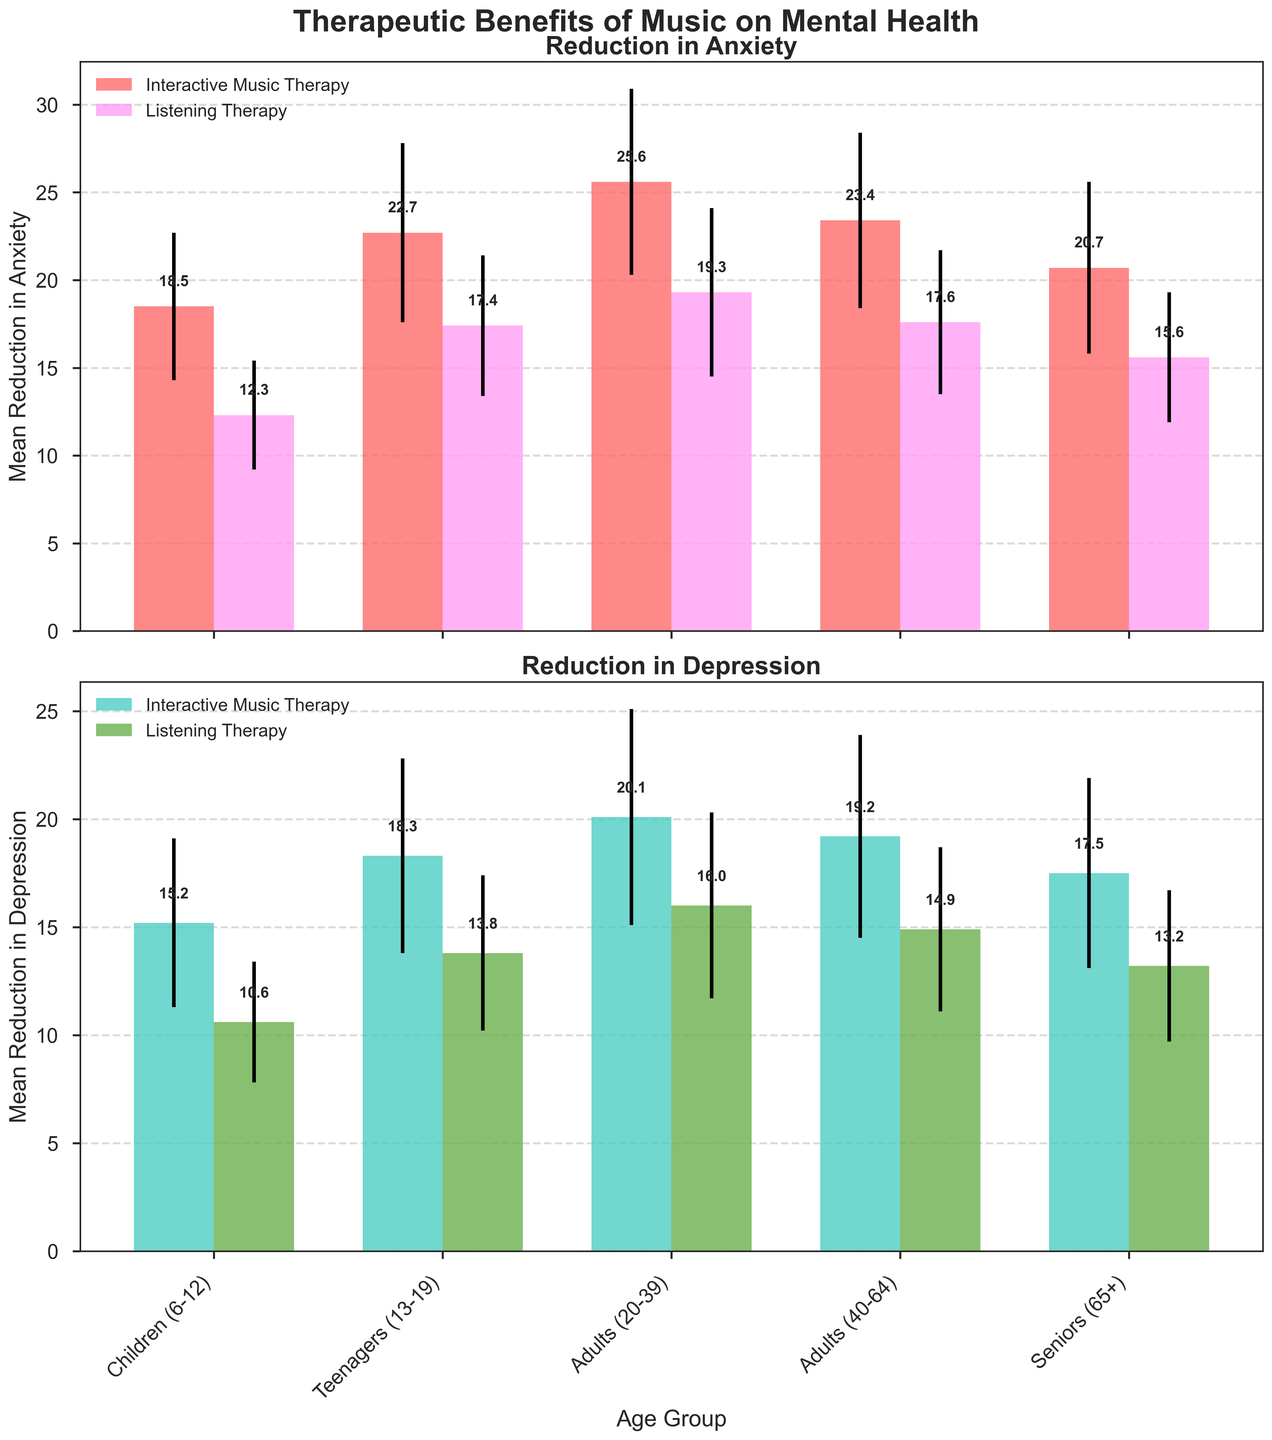Which age group has the highest mean reduction in anxiety with Interactive Music Therapy? To find this, look at the top subplot "Reduction in Anxiety" and compare the heights of the red bars for all age groups. The highest red bar corresponds to Adults (20-39) with a mean reduction of 25.6.
Answer: Adults (20-39) What is the average mean reduction in depression for Listening Therapy across all age groups? Calculate the average by summing the mean reductions in depression for Listening Therapy for all age groups and dividing by the number of age groups. (15.2 + 10.6 + 18.3 + 13.8 + 20.1 + 16.0 + 19.2 + 14.9 + 17.5 + 13.2) / 10 = 14.76
Answer: 14.76 Which type of music therapy shows a higher mean reduction in anxiety for Seniors (65+)? Compare the heights of the two bars for Seniors (65+) in the top subplot "Reduction in Anxiety." The red bar (Interactive Music Therapy) is higher than the green bar (Listening Therapy), indicating a higher mean reduction.
Answer: Interactive Music Therapy What is the difference in mean reduction in depression between Interactive and Listening Therapy for Teenagers (13-19)? Find the mean reduction values for both therapies for Teenagers (13-19) in the bottom subplot "Reduction in Depression." The difference is 18.3 (Interactive) - 13.8 (Listening) = 4.5.
Answer: 4.5 How much greater is the reduction in anxiety in Interactive Music Therapy compared to Listening Therapy for Adults (20-39)? Check the "Reduction in Anxiety" subplot for Adults (20-39). The red bar (Interactive) height is 25.6, and the green bar (Listening) height is 19.3. The difference is 25.6 - 19.3 = 6.3.
Answer: 6.3 Which age group shows the smallest standard deviation in reduction in depression for Listening Therapy? Look for the smallest error bar on green bars in the bottom subplot "Reduction in Depression." The smallest error bar corresponds to Children (6-12) with a standard deviation of 2.8.
Answer: Children (6-12) What is the combined mean reduction in anxiety for Interactive Music Therapy across all age groups? Add the mean reduction in anxiety for Interactive Music Therapy for all age groups: 18.5 (Children) + 22.7 (Teenagers) + 25.6 (Adults 20-39) + 23.4 (Adults 40-64) + 20.7 (Seniors) = 110.9.
Answer: 110.9 Among all age groups, which one has the closest mean reduction in depression for both Interactive and Listening Therapy? Compare the corresponding bars in the bottom subplot "Reduction in Depression." Adults (40-64) have the closest mean reduction: 19.2 (Interactive) and 14.9 (Listening), with a difference of 19.2 - 14.9 = 4.3.
Answer: Adults (40-64) Is the mean reduction in anxiety higher for Adults (40-64) using Listening Therapy or for Children (6-12) using Interactive Music Therapy? Compare the heights of the green bar (Listening Therapy) for Adults (40-64) in the top subplot with the red bar (Interactive Music Therapy) for Children (6-12). 17.6 (Adults, Listening) is less than 18.5 (Children, Interactive). Therefore, it's higher for Children (6-12) using Interactive Music Therapy.
Answer: Children (6-12) What is the ratio of mean reduction in depression between Listening Therapy and Interactive Music Therapy for Seniors (65+)? Find the mean reduction in depression values for both therapies for Seniors (65+): 17.5 (Interactive) and 13.2 (Listening). The ratio is 13.2 / 17.5 ≈ 0.754.
Answer: 0.754 